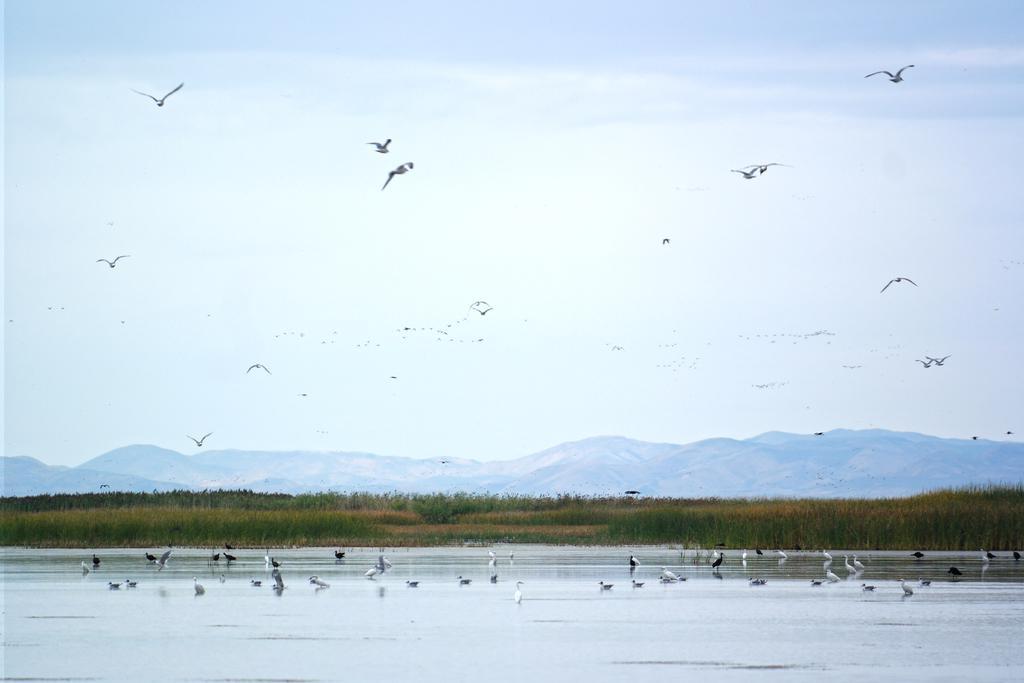Can you describe this image briefly? We can see birds and water and few birds flying in the air. In the background we can see grass,hills and sky. 